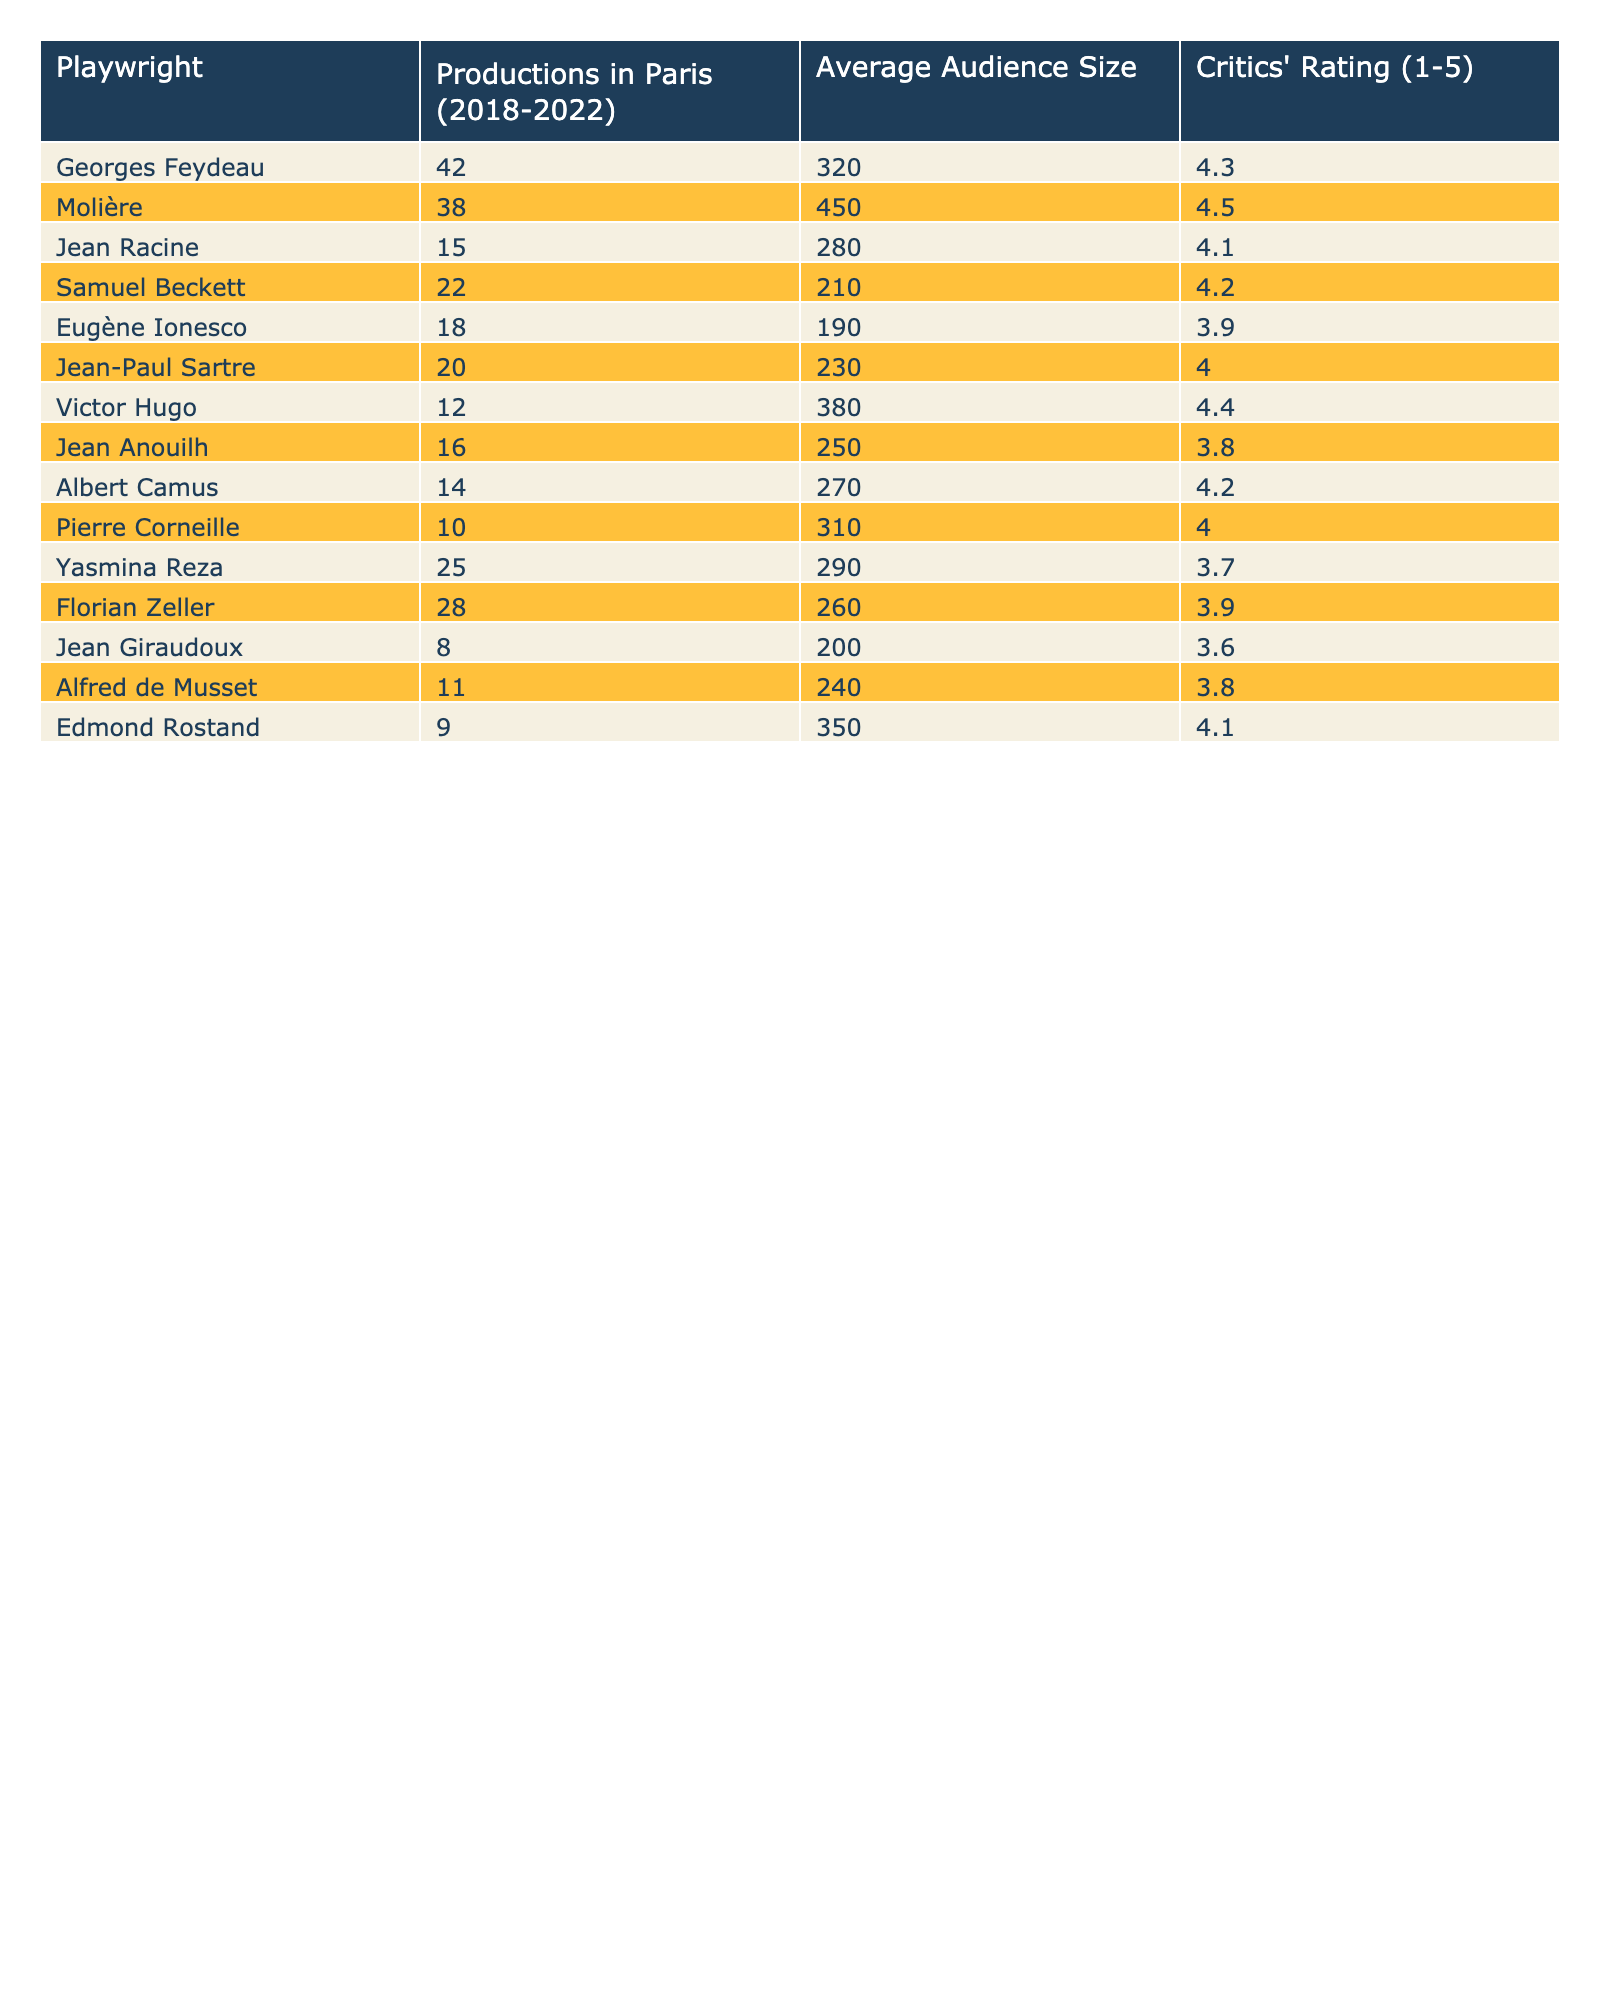What is the total number of productions by Georges Feydeau in Paris during 2018-2022? The table states that Georges Feydeau had 42 productions in Paris from 2018 to 2022.
Answer: 42 Which playwright had the highest average audience size? The table shows that Molière had the highest average audience size of 450.
Answer: Molière How many productions did Jean Racine have compared to Georges Feydeau? Jean Racine had 15 productions, while Georges Feydeau had 42 productions, meaning Feydeau had 27 more productions than Racine.
Answer: 27 more Is it true that Albert Camus received a critics' rating of 4.5? The table indicates Albert Camus has a rating of 4.2, not 4.5, so this statement is false.
Answer: False What is the difference in the number of productions between Molière and Eugène Ionesco? Molière had 38 productions, and Eugène Ionesco had 18 productions, so the difference is 38 - 18 = 20 productions.
Answer: 20 Which playwright had the lowest critics' rating and what was that rating? The table indicates Jean Giraudoux had the lowest critics' rating at 3.6.
Answer: 3.6 If we combine the productions of both Samuel Beckett and Yasmina Reza, how many productions do they have in total? Samuel Beckett had 22 productions and Yasmina Reza had 25, thus the total is 22 + 25 = 47 productions.
Answer: 47 How does the average audience size of Jean-Paul Sartre compare to that of Victor Hugo? Jean-Paul Sartre had an average audience size of 230, while Victor Hugo had 380, which means Hugo had 150 more.
Answer: 150 more Which playwright has a higher critics' rating: Florian Zeller or Jean Anouilh? Florian Zeller has a rating of 3.9 and Jean Anouilh has a rating of 3.8, making Zeller the higher rated playwright.
Answer: Florian Zeller How many more total productions did Feydeau and Molière have combined compared to Racine and Ionesco? Combining Feydeau (42) and Molière (38), they have 80 productions, while Racine (15) and Ionesco (18) have 33. The difference is 80 - 33 = 47.
Answer: 47 